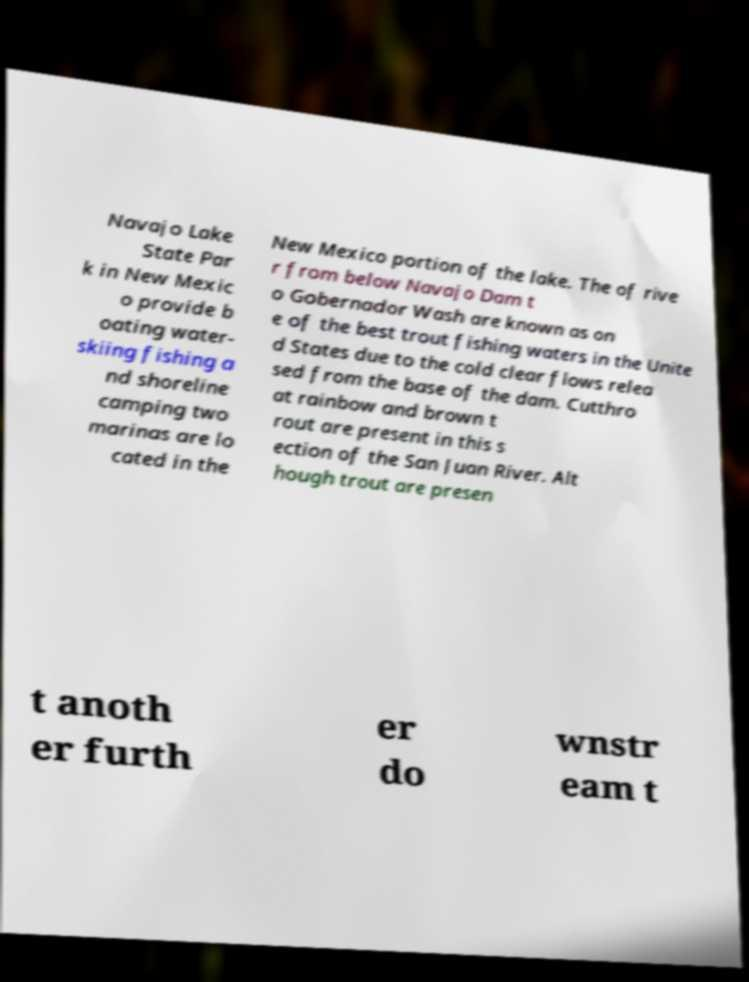What messages or text are displayed in this image? I need them in a readable, typed format. Navajo Lake State Par k in New Mexic o provide b oating water- skiing fishing a nd shoreline camping two marinas are lo cated in the New Mexico portion of the lake. The of rive r from below Navajo Dam t o Gobernador Wash are known as on e of the best trout fishing waters in the Unite d States due to the cold clear flows relea sed from the base of the dam. Cutthro at rainbow and brown t rout are present in this s ection of the San Juan River. Alt hough trout are presen t anoth er furth er do wnstr eam t 